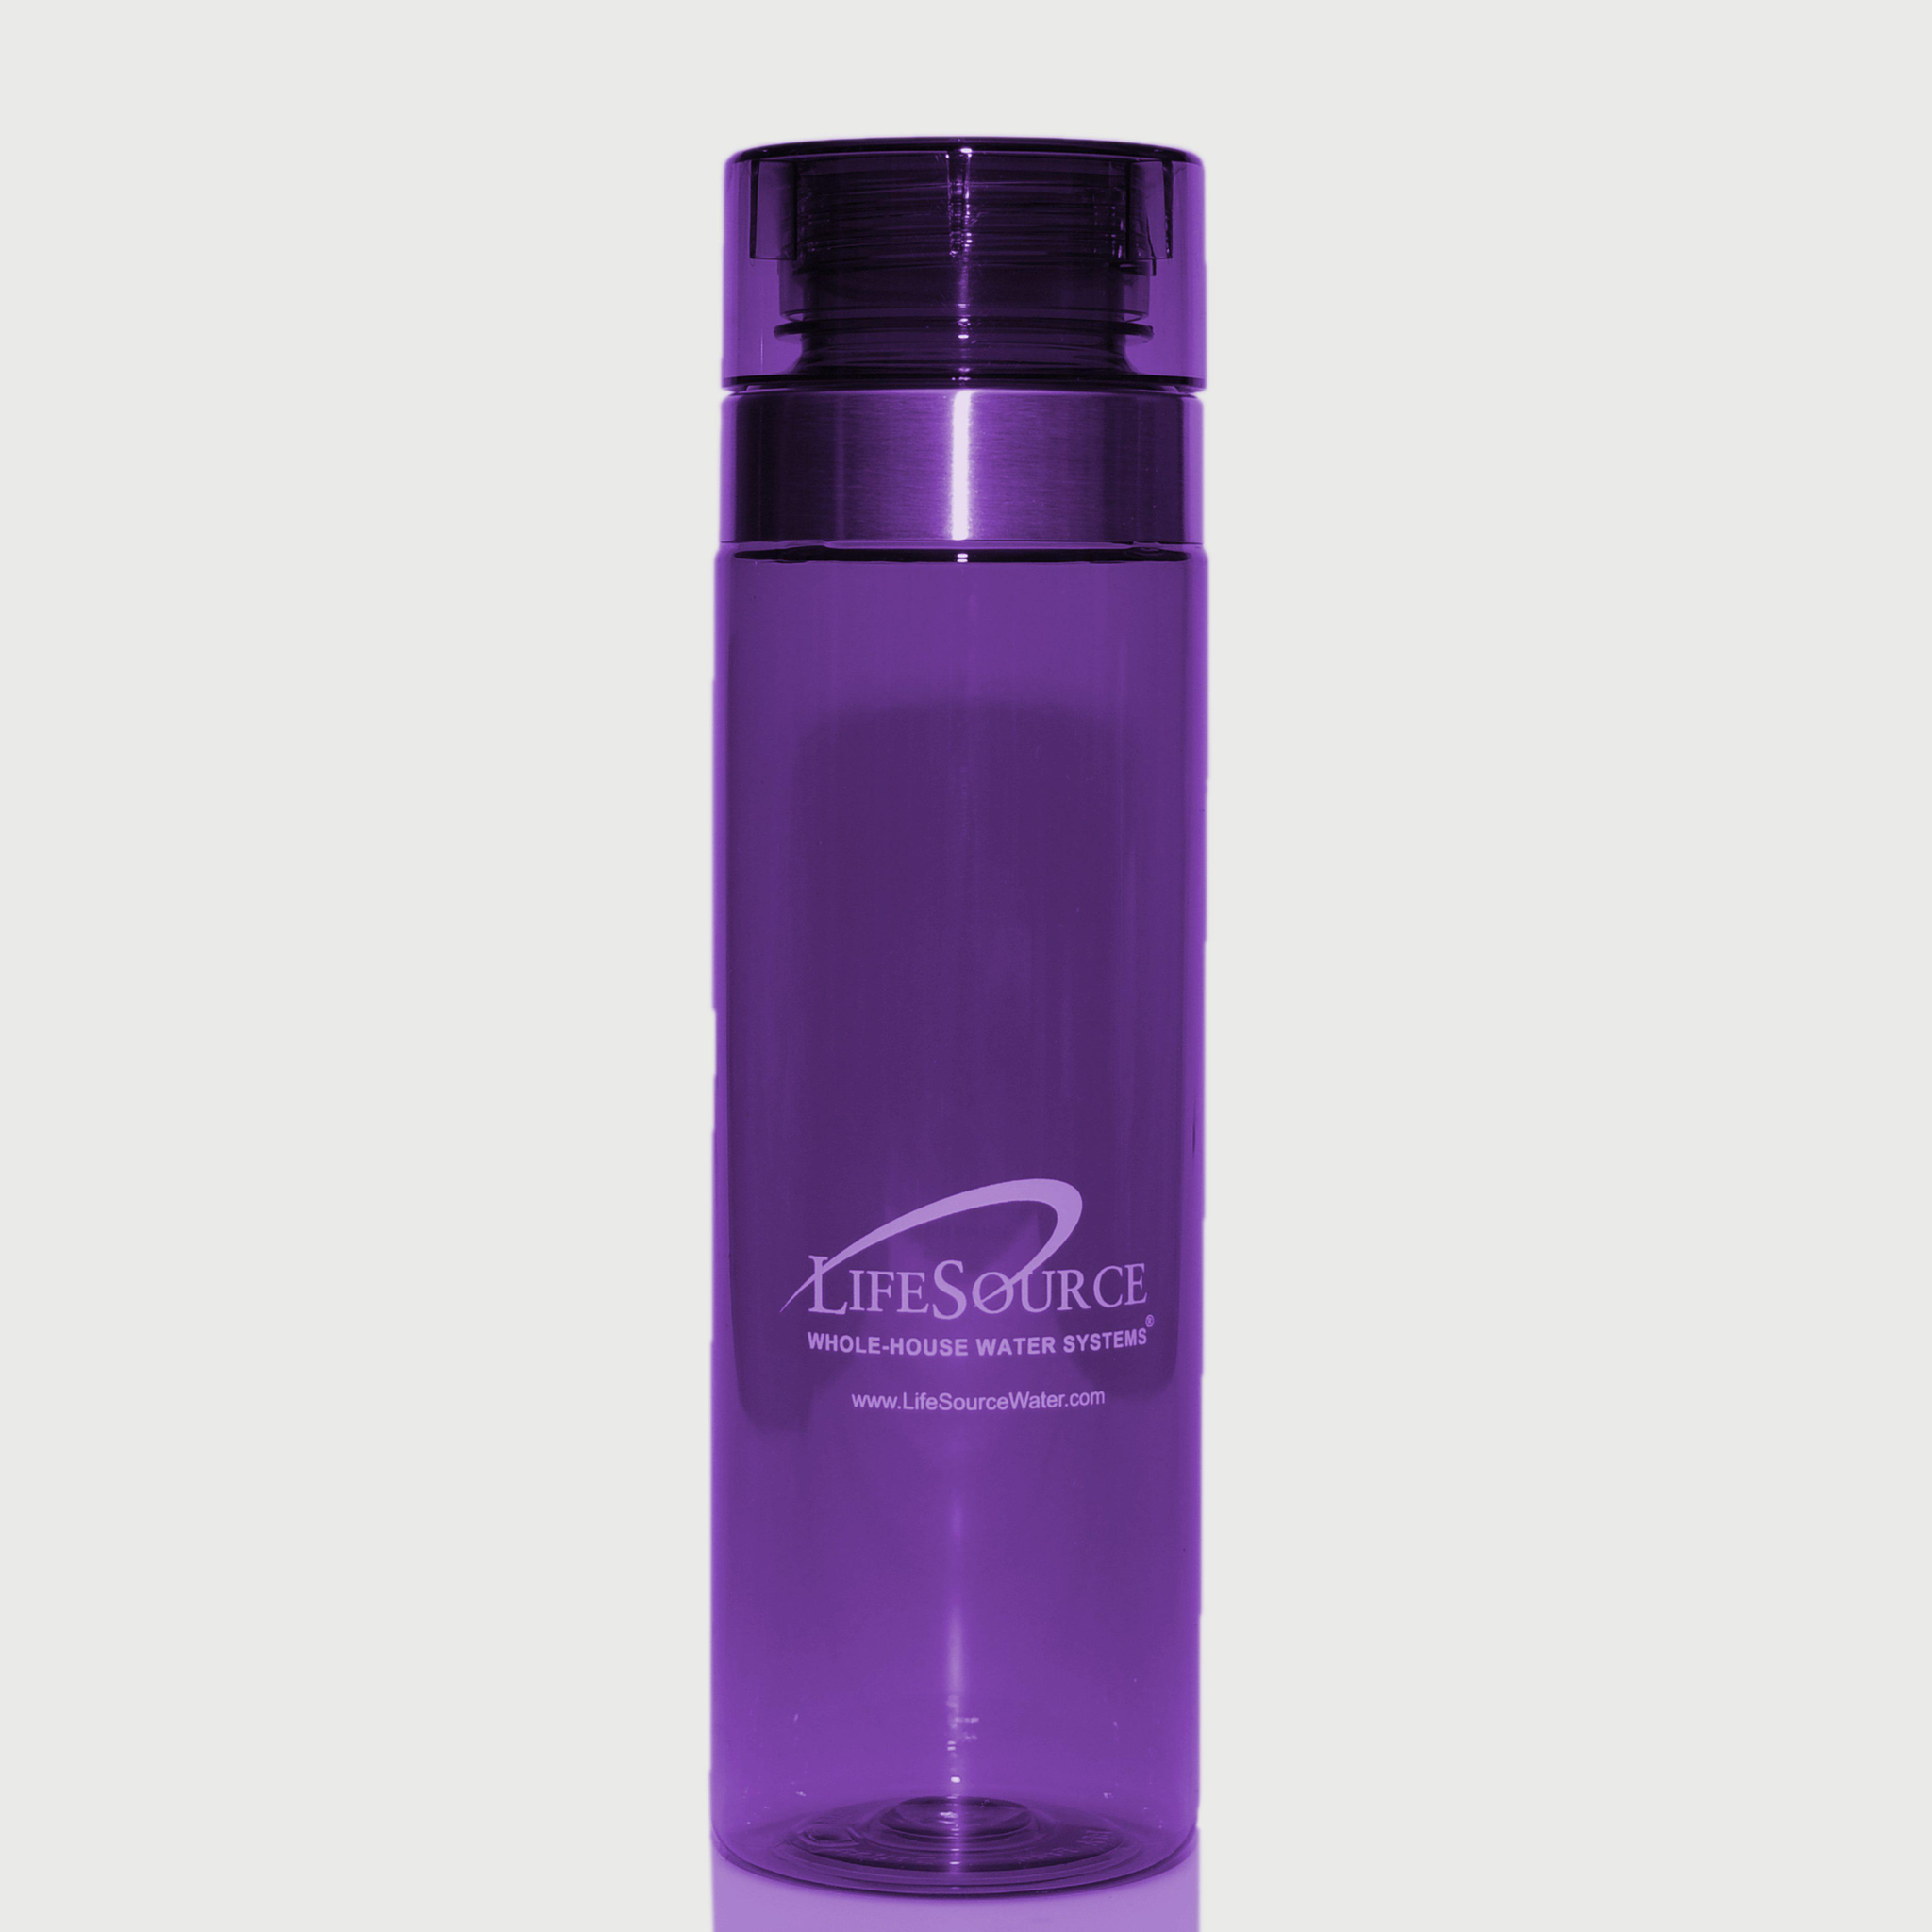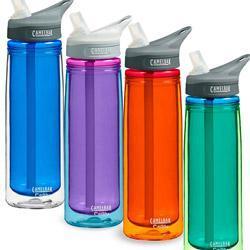The first image is the image on the left, the second image is the image on the right. Assess this claim about the two images: "Out of the two bottles, one is blue.". Correct or not? Answer yes or no. No. The first image is the image on the left, the second image is the image on the right. Analyze the images presented: Is the assertion "An image contains exactly one vivid purple upright water bottle." valid? Answer yes or no. Yes. 